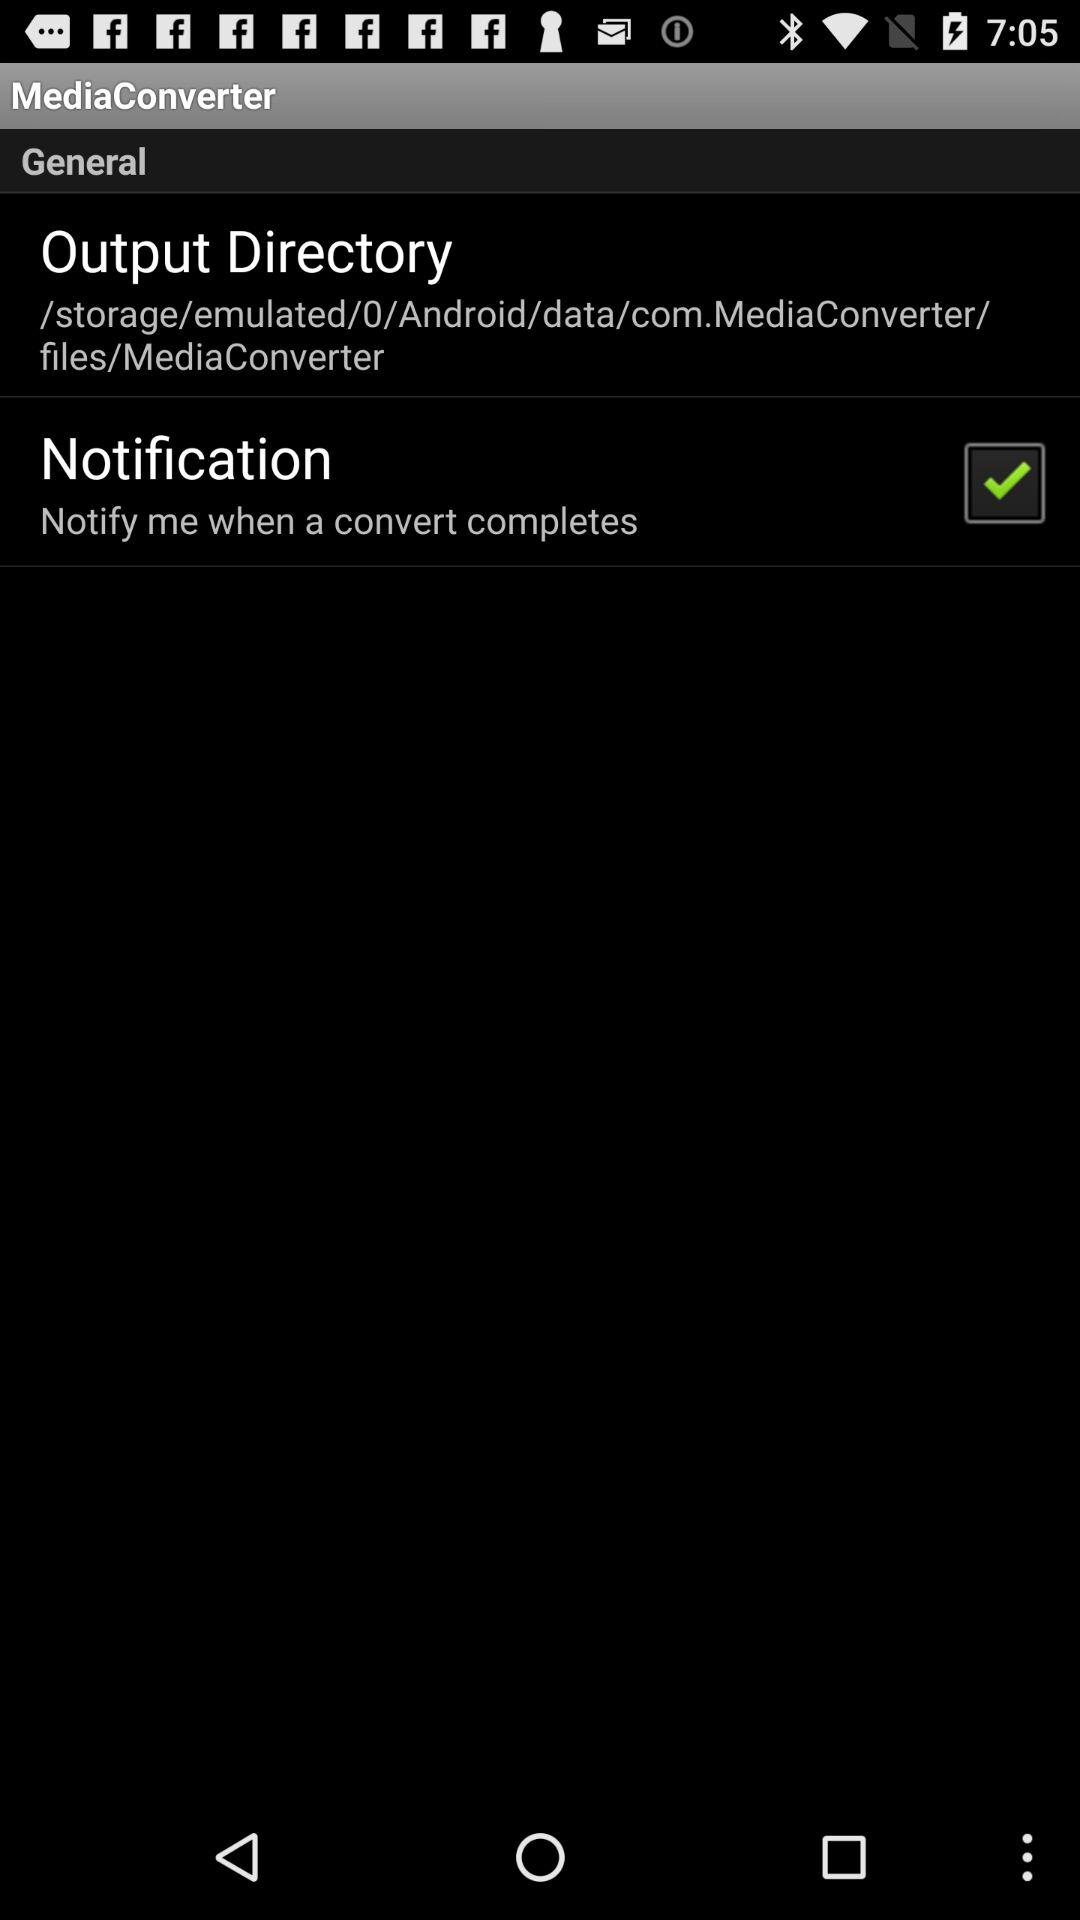How many items are in the general section?
Answer the question using a single word or phrase. 2 